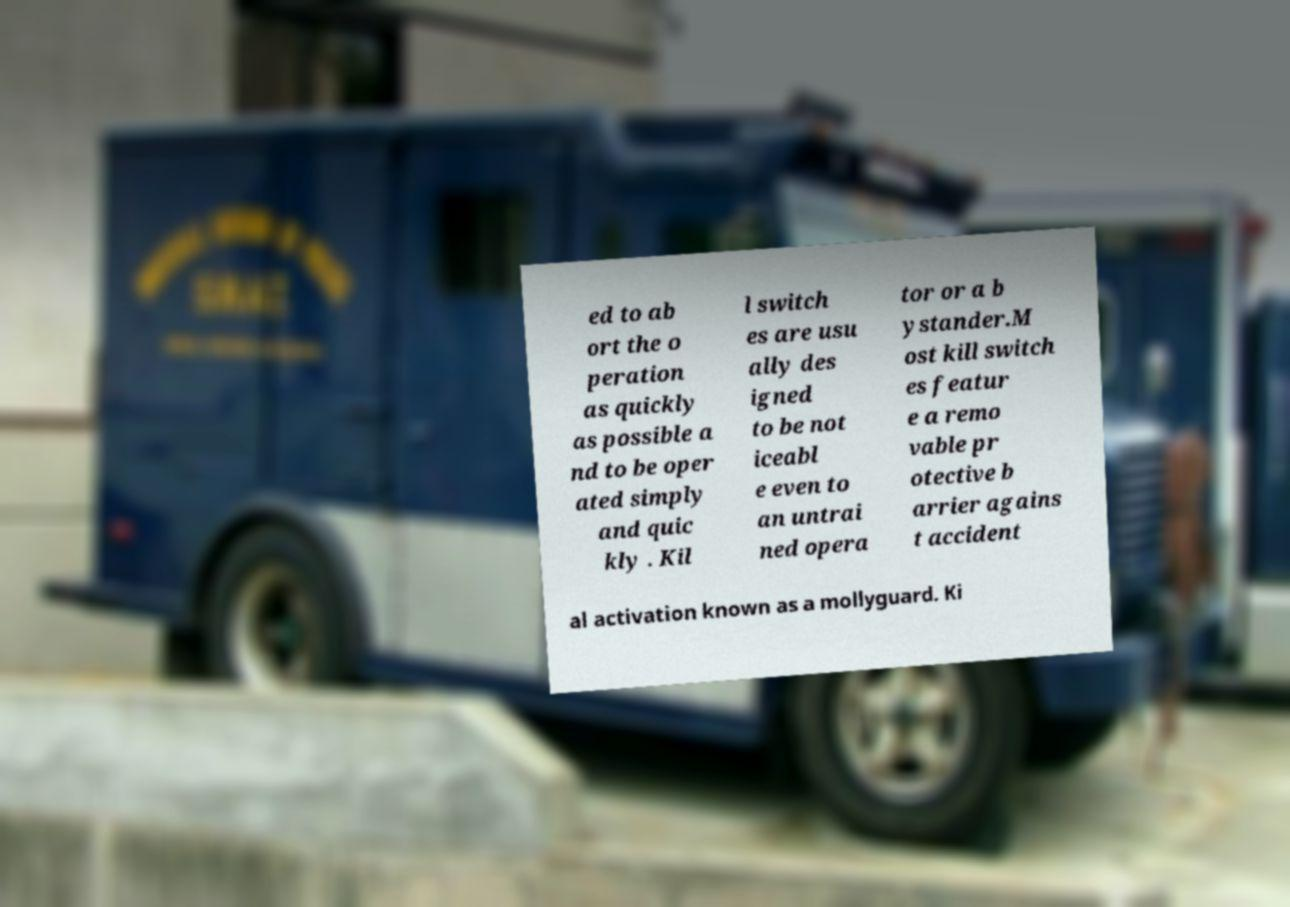Can you accurately transcribe the text from the provided image for me? ed to ab ort the o peration as quickly as possible a nd to be oper ated simply and quic kly . Kil l switch es are usu ally des igned to be not iceabl e even to an untrai ned opera tor or a b ystander.M ost kill switch es featur e a remo vable pr otective b arrier agains t accident al activation known as a mollyguard. Ki 